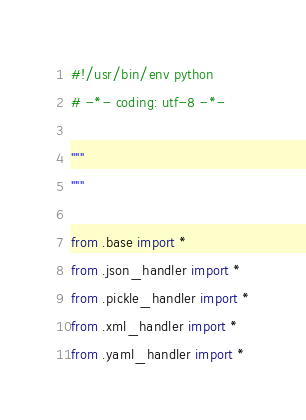<code> <loc_0><loc_0><loc_500><loc_500><_Python_>#!/usr/bin/env python
# -*- coding: utf-8 -*-

"""
"""

from .base import *
from .json_handler import *
from .pickle_handler import *
from .xml_handler import *
from .yaml_handler import *
</code> 